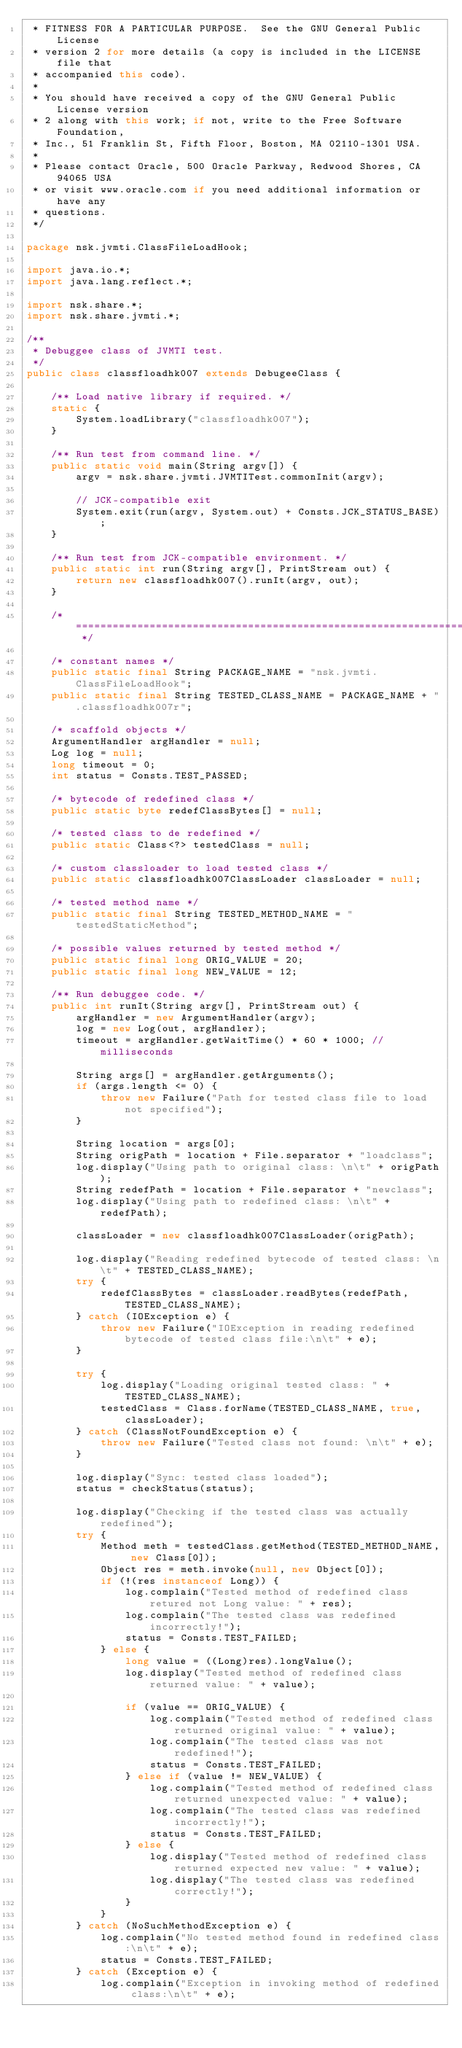<code> <loc_0><loc_0><loc_500><loc_500><_Java_> * FITNESS FOR A PARTICULAR PURPOSE.  See the GNU General Public License
 * version 2 for more details (a copy is included in the LICENSE file that
 * accompanied this code).
 *
 * You should have received a copy of the GNU General Public License version
 * 2 along with this work; if not, write to the Free Software Foundation,
 * Inc., 51 Franklin St, Fifth Floor, Boston, MA 02110-1301 USA.
 *
 * Please contact Oracle, 500 Oracle Parkway, Redwood Shores, CA 94065 USA
 * or visit www.oracle.com if you need additional information or have any
 * questions.
 */

package nsk.jvmti.ClassFileLoadHook;

import java.io.*;
import java.lang.reflect.*;

import nsk.share.*;
import nsk.share.jvmti.*;

/**
 * Debuggee class of JVMTI test.
 */
public class classfloadhk007 extends DebugeeClass {

    /** Load native library if required. */
    static {
        System.loadLibrary("classfloadhk007");
    }

    /** Run test from command line. */
    public static void main(String argv[]) {
        argv = nsk.share.jvmti.JVMTITest.commonInit(argv);

        // JCK-compatible exit
        System.exit(run(argv, System.out) + Consts.JCK_STATUS_BASE);
    }

    /** Run test from JCK-compatible environment. */
    public static int run(String argv[], PrintStream out) {
        return new classfloadhk007().runIt(argv, out);
    }

    /* =================================================================== */

    /* constant names */
    public static final String PACKAGE_NAME = "nsk.jvmti.ClassFileLoadHook";
    public static final String TESTED_CLASS_NAME = PACKAGE_NAME + ".classfloadhk007r";

    /* scaffold objects */
    ArgumentHandler argHandler = null;
    Log log = null;
    long timeout = 0;
    int status = Consts.TEST_PASSED;

    /* bytecode of redefined class */
    public static byte redefClassBytes[] = null;

    /* tested class to de redefined */
    public static Class<?> testedClass = null;

    /* custom classloader to load tested class */
    public static classfloadhk007ClassLoader classLoader = null;

    /* tested method name */
    public static final String TESTED_METHOD_NAME = "testedStaticMethod";

    /* possible values returned by tested method */
    public static final long ORIG_VALUE = 20;
    public static final long NEW_VALUE = 12;

    /** Run debuggee code. */
    public int runIt(String argv[], PrintStream out) {
        argHandler = new ArgumentHandler(argv);
        log = new Log(out, argHandler);
        timeout = argHandler.getWaitTime() * 60 * 1000; // milliseconds

        String args[] = argHandler.getArguments();
        if (args.length <= 0) {
            throw new Failure("Path for tested class file to load not specified");
        }

        String location = args[0];
        String origPath = location + File.separator + "loadclass";
        log.display("Using path to original class: \n\t" + origPath);
        String redefPath = location + File.separator + "newclass";
        log.display("Using path to redefined class: \n\t" + redefPath);

        classLoader = new classfloadhk007ClassLoader(origPath);

        log.display("Reading redefined bytecode of tested class: \n\t" + TESTED_CLASS_NAME);
        try {
            redefClassBytes = classLoader.readBytes(redefPath, TESTED_CLASS_NAME);
        } catch (IOException e) {
            throw new Failure("IOException in reading redefined bytecode of tested class file:\n\t" + e);
        }

        try {
            log.display("Loading original tested class: " + TESTED_CLASS_NAME);
            testedClass = Class.forName(TESTED_CLASS_NAME, true, classLoader);
        } catch (ClassNotFoundException e) {
            throw new Failure("Tested class not found: \n\t" + e);
        }

        log.display("Sync: tested class loaded");
        status = checkStatus(status);

        log.display("Checking if the tested class was actually redefined");
        try {
            Method meth = testedClass.getMethod(TESTED_METHOD_NAME, new Class[0]);
            Object res = meth.invoke(null, new Object[0]);
            if (!(res instanceof Long)) {
                log.complain("Tested method of redefined class retured not Long value: " + res);
                log.complain("The tested class was redefined incorrectly!");
                status = Consts.TEST_FAILED;
            } else {
                long value = ((Long)res).longValue();
                log.display("Tested method of redefined class returned value: " + value);

                if (value == ORIG_VALUE) {
                    log.complain("Tested method of redefined class returned original value: " + value);
                    log.complain("The tested class was not redefined!");
                    status = Consts.TEST_FAILED;
                } else if (value != NEW_VALUE) {
                    log.complain("Tested method of redefined class returned unexpected value: " + value);
                    log.complain("The tested class was redefined incorrectly!");
                    status = Consts.TEST_FAILED;
                } else {
                    log.display("Tested method of redefined class returned expected new value: " + value);
                    log.display("The tested class was redefined correctly!");
                }
            }
        } catch (NoSuchMethodException e) {
            log.complain("No tested method found in redefined class:\n\t" + e);
            status = Consts.TEST_FAILED;
        } catch (Exception e) {
            log.complain("Exception in invoking method of redefined class:\n\t" + e);</code> 